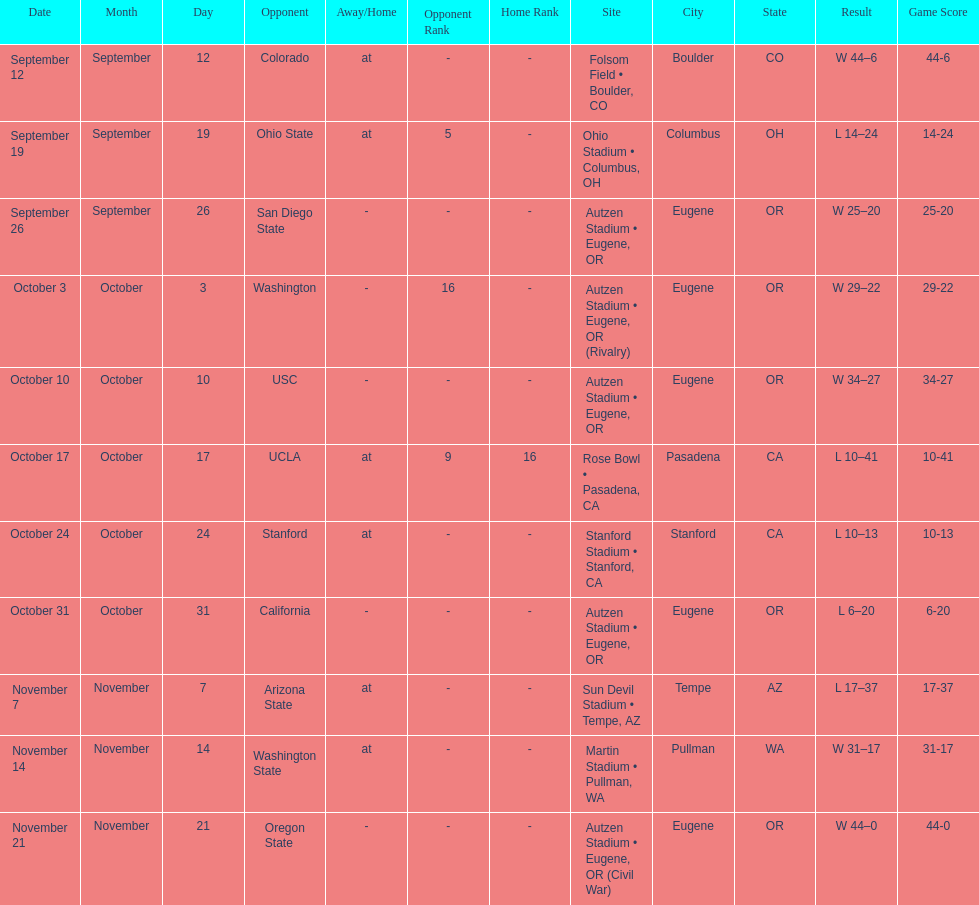Were the results of the game of november 14 above or below the results of the october 17 game? Above. 